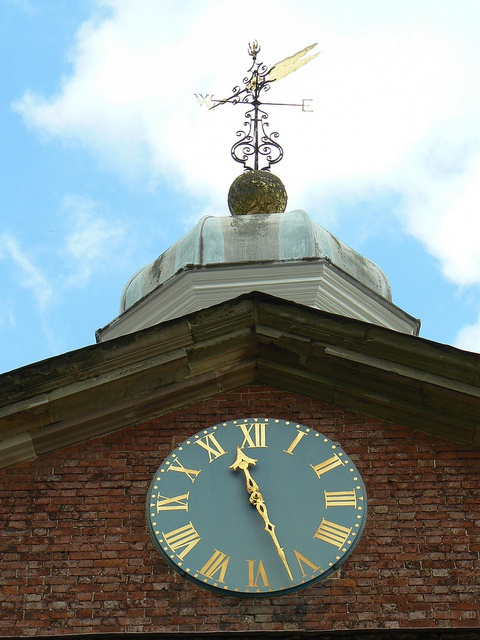Describe the objects in this image and their specific colors. I can see a clock in lightblue, teal, gray, and khaki tones in this image. 